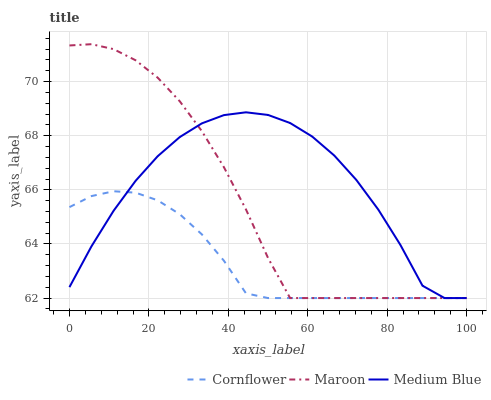Does Cornflower have the minimum area under the curve?
Answer yes or no. Yes. Does Medium Blue have the maximum area under the curve?
Answer yes or no. Yes. Does Maroon have the minimum area under the curve?
Answer yes or no. No. Does Maroon have the maximum area under the curve?
Answer yes or no. No. Is Cornflower the smoothest?
Answer yes or no. Yes. Is Medium Blue the roughest?
Answer yes or no. Yes. Is Maroon the smoothest?
Answer yes or no. No. Is Maroon the roughest?
Answer yes or no. No. Does Medium Blue have the highest value?
Answer yes or no. No. 